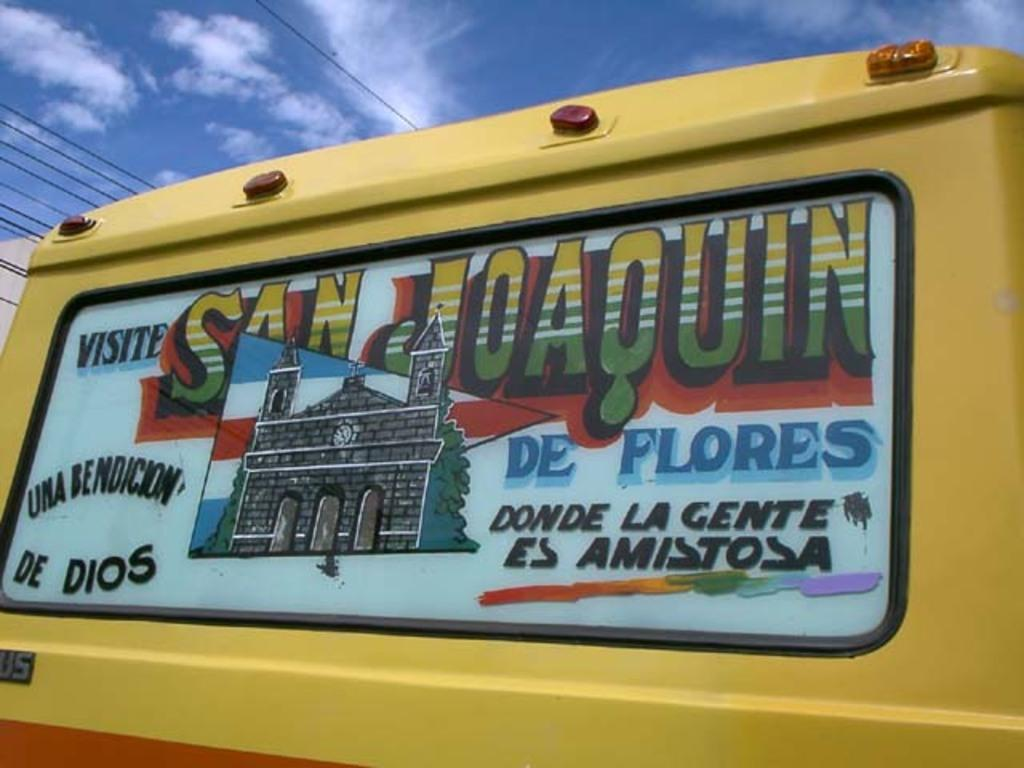What is the main subject in the foreground of the image? There is a vehicle in the foreground of the image. What is on the vehicle? There is a poster on the vehicle. What can be seen at the top of the image? Cables and the sky are visible at the top of the image. Can you describe the sky in the image? The sky is visible at the top of the image, and there is a cloud in the sky. What color is the wool on the eye of the person in the image? There is no person, eye, or wool present in the image. 